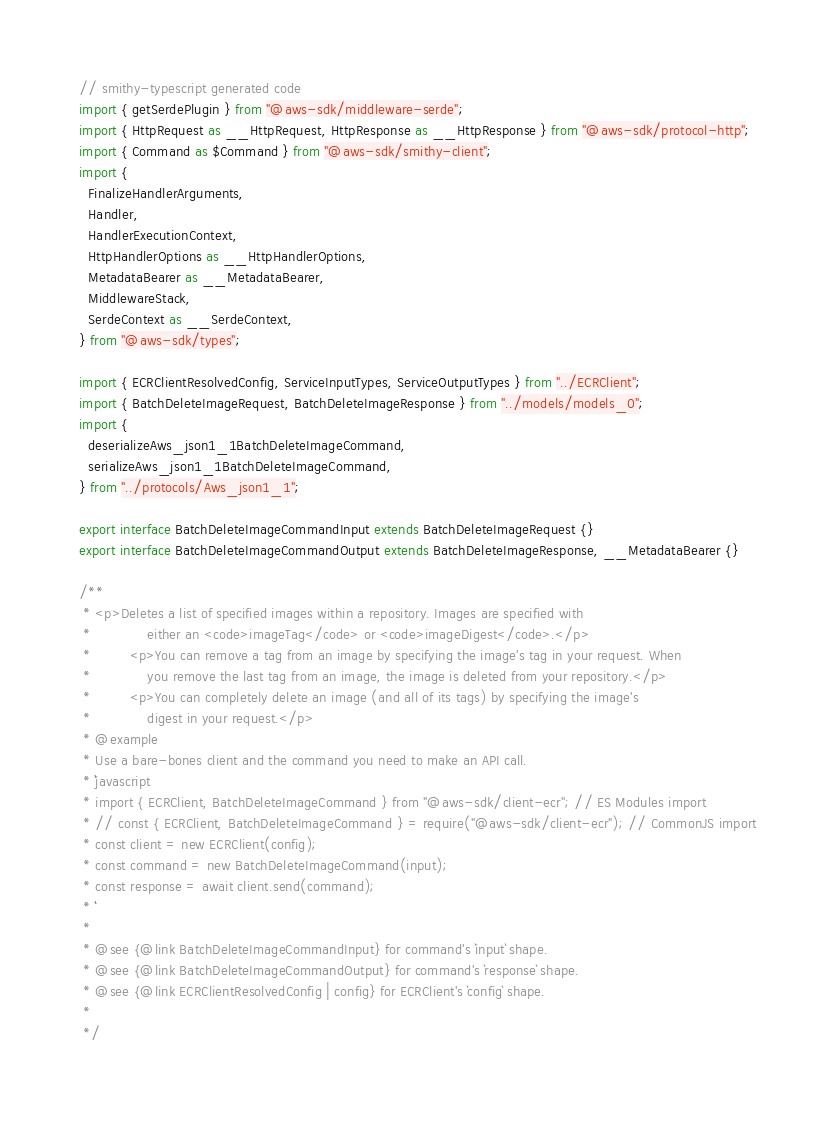Convert code to text. <code><loc_0><loc_0><loc_500><loc_500><_TypeScript_>// smithy-typescript generated code
import { getSerdePlugin } from "@aws-sdk/middleware-serde";
import { HttpRequest as __HttpRequest, HttpResponse as __HttpResponse } from "@aws-sdk/protocol-http";
import { Command as $Command } from "@aws-sdk/smithy-client";
import {
  FinalizeHandlerArguments,
  Handler,
  HandlerExecutionContext,
  HttpHandlerOptions as __HttpHandlerOptions,
  MetadataBearer as __MetadataBearer,
  MiddlewareStack,
  SerdeContext as __SerdeContext,
} from "@aws-sdk/types";

import { ECRClientResolvedConfig, ServiceInputTypes, ServiceOutputTypes } from "../ECRClient";
import { BatchDeleteImageRequest, BatchDeleteImageResponse } from "../models/models_0";
import {
  deserializeAws_json1_1BatchDeleteImageCommand,
  serializeAws_json1_1BatchDeleteImageCommand,
} from "../protocols/Aws_json1_1";

export interface BatchDeleteImageCommandInput extends BatchDeleteImageRequest {}
export interface BatchDeleteImageCommandOutput extends BatchDeleteImageResponse, __MetadataBearer {}

/**
 * <p>Deletes a list of specified images within a repository. Images are specified with
 *             either an <code>imageTag</code> or <code>imageDigest</code>.</p>
 *         <p>You can remove a tag from an image by specifying the image's tag in your request. When
 *             you remove the last tag from an image, the image is deleted from your repository.</p>
 *         <p>You can completely delete an image (and all of its tags) by specifying the image's
 *             digest in your request.</p>
 * @example
 * Use a bare-bones client and the command you need to make an API call.
 * ```javascript
 * import { ECRClient, BatchDeleteImageCommand } from "@aws-sdk/client-ecr"; // ES Modules import
 * // const { ECRClient, BatchDeleteImageCommand } = require("@aws-sdk/client-ecr"); // CommonJS import
 * const client = new ECRClient(config);
 * const command = new BatchDeleteImageCommand(input);
 * const response = await client.send(command);
 * ```
 *
 * @see {@link BatchDeleteImageCommandInput} for command's `input` shape.
 * @see {@link BatchDeleteImageCommandOutput} for command's `response` shape.
 * @see {@link ECRClientResolvedConfig | config} for ECRClient's `config` shape.
 *
 */</code> 